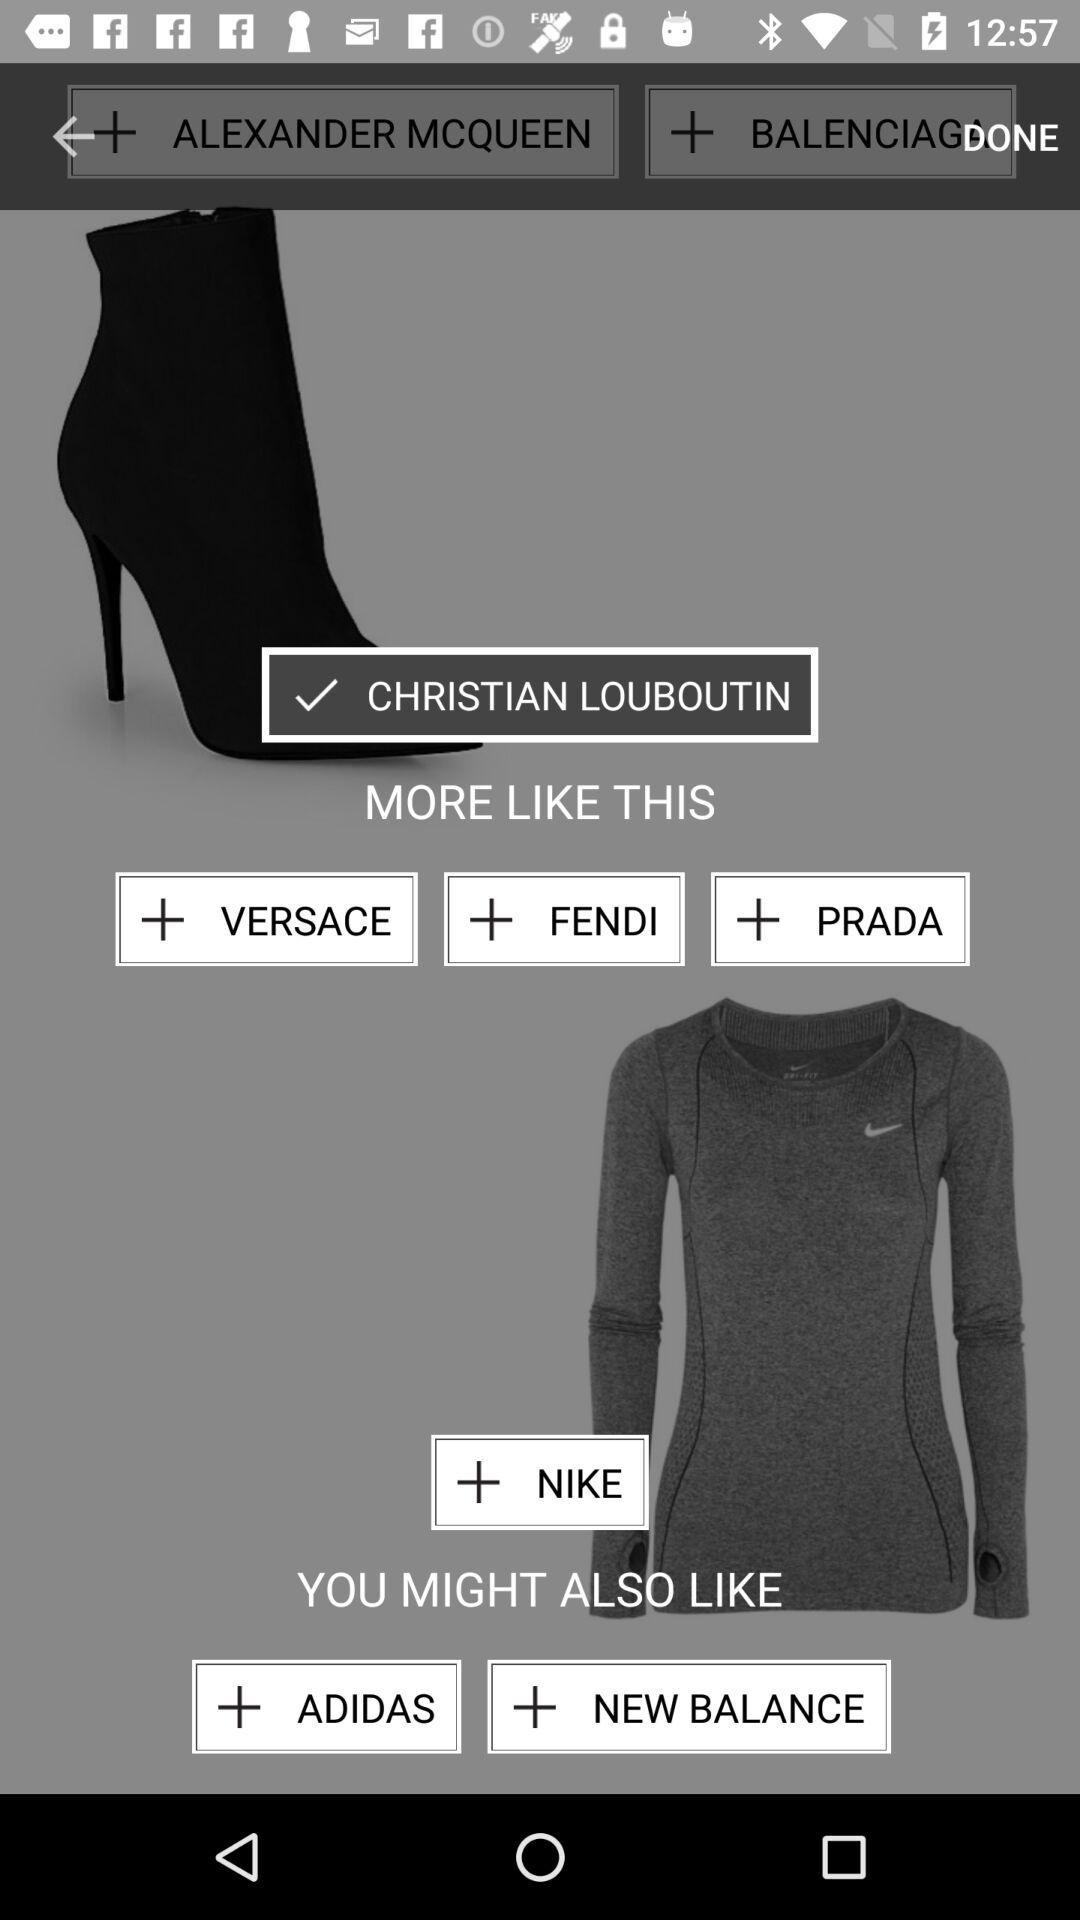Which brand is selected? The selected brand is "CHRISTIAN LOUBOUTIN". 